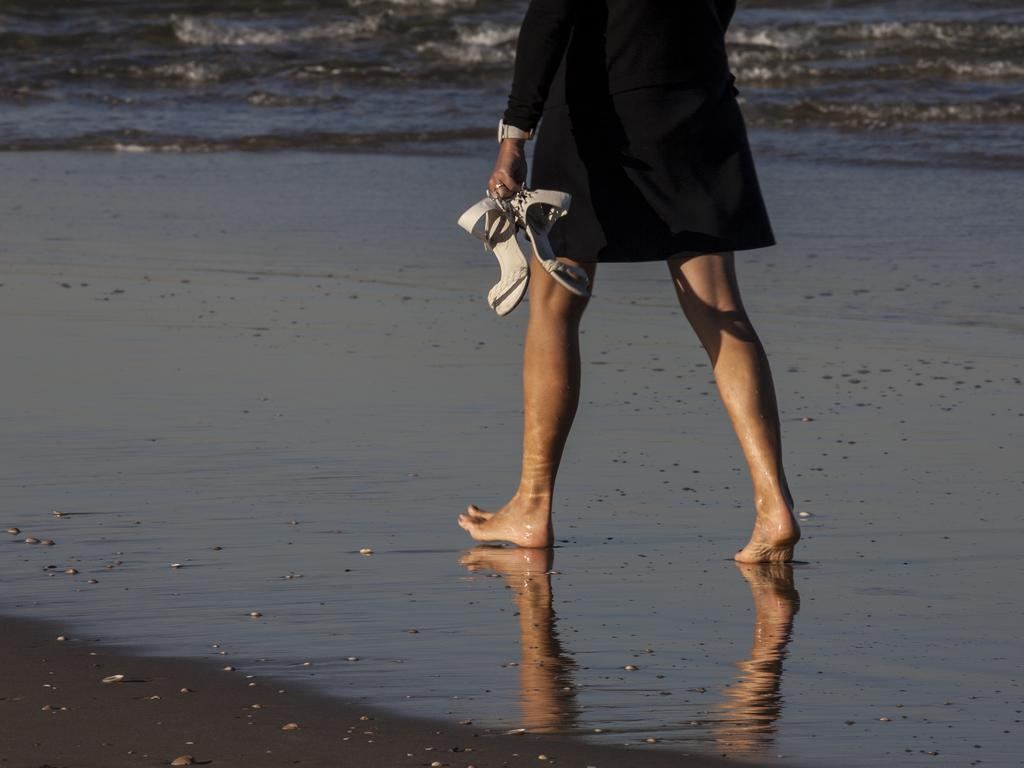Who is present in the image? There is a woman in the image. What is the woman doing in the image? The woman is walking on the shore. What is the woman holding in her hands? The woman is holding heels in her hands. What type of terrain is visible at the bottom of the image? There is sand visible at the bottom of the image. What type of water body is visible at the top of the image? There is an ocean visible at the top of the image. How many brothers does the woman have, and what are they doing in the image? There is no information about the woman's brothers in the image, nor is there any indication of their presence or activities. 